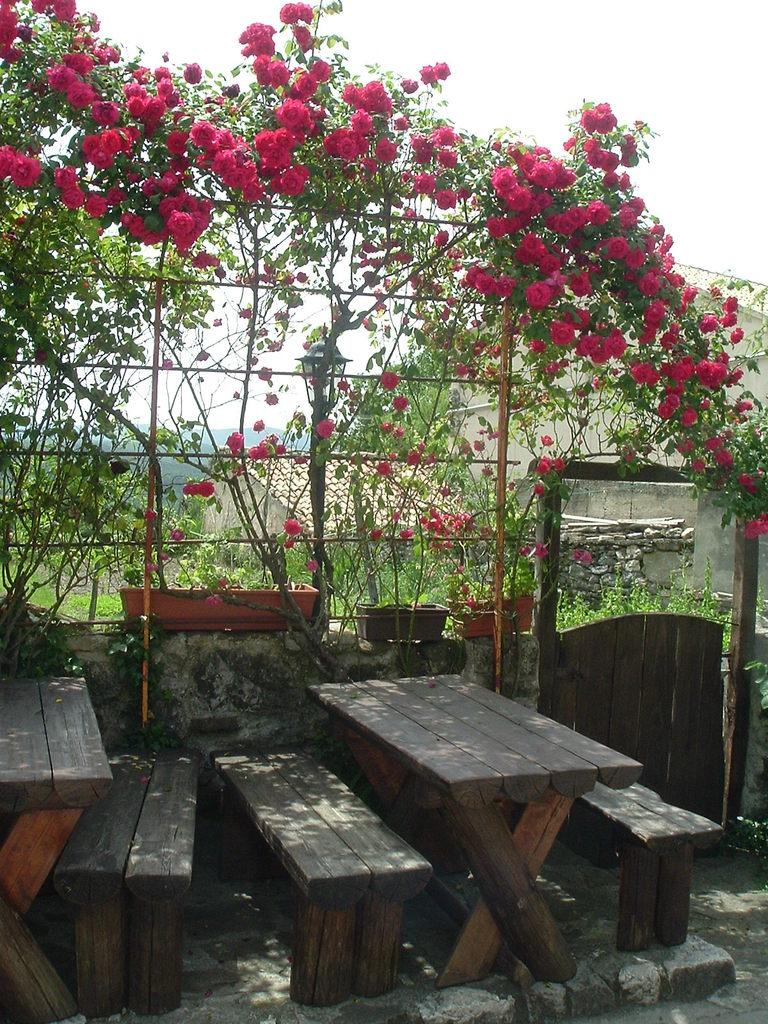What type of plants can be seen in the image? There are plants with pink flowers in the image. What type of seating is available in the image? There are benches in the image. What can be seen in the background of the image? The sky is visible in the background of the image. What type of structure is present in the image? There is a house in the image. What type of temper do the plants with pink flowers have in the image? The plants with pink flowers do not have a temper; they are inanimate objects and cannot exhibit emotions or temperament. 